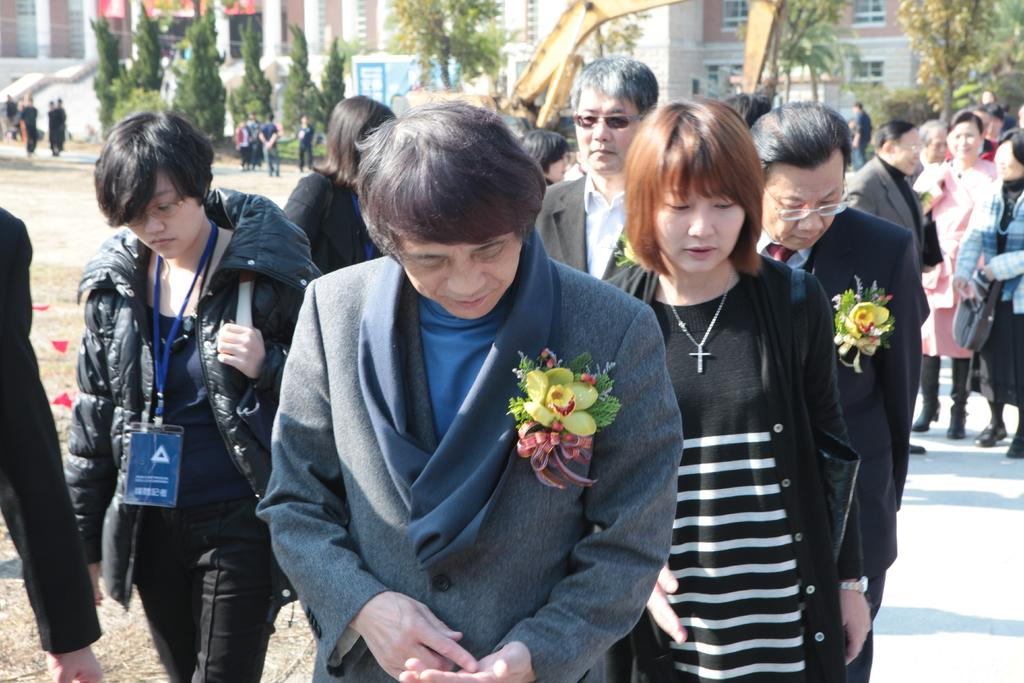What are the people in the image doing? The people in the image are walking on a path. What can be seen in the background of the image? There is a crane, trees, and a building in the background of the image. Can you tell me how many squirrels are working under the authority of the crane in the image? There are no squirrels or any indication of work or authority present in the image. 